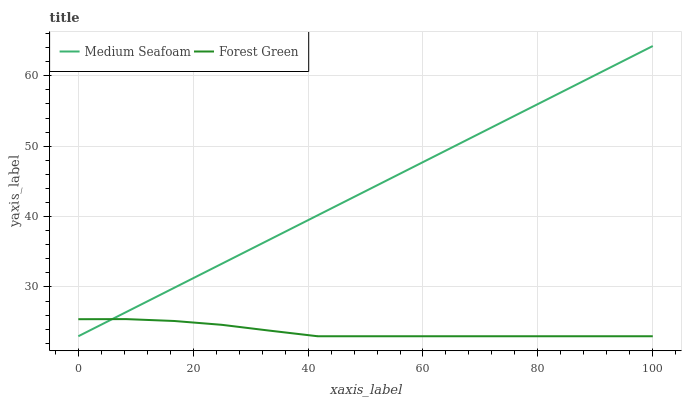Does Forest Green have the minimum area under the curve?
Answer yes or no. Yes. Does Medium Seafoam have the maximum area under the curve?
Answer yes or no. Yes. Does Medium Seafoam have the minimum area under the curve?
Answer yes or no. No. Is Medium Seafoam the smoothest?
Answer yes or no. Yes. Is Forest Green the roughest?
Answer yes or no. Yes. Is Medium Seafoam the roughest?
Answer yes or no. No. Does Medium Seafoam have the highest value?
Answer yes or no. Yes. 